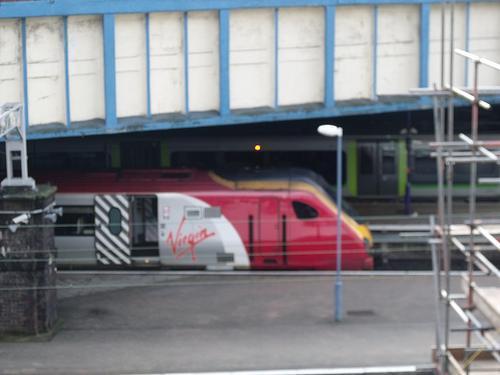How many trains do you see?
Give a very brief answer. 2. 